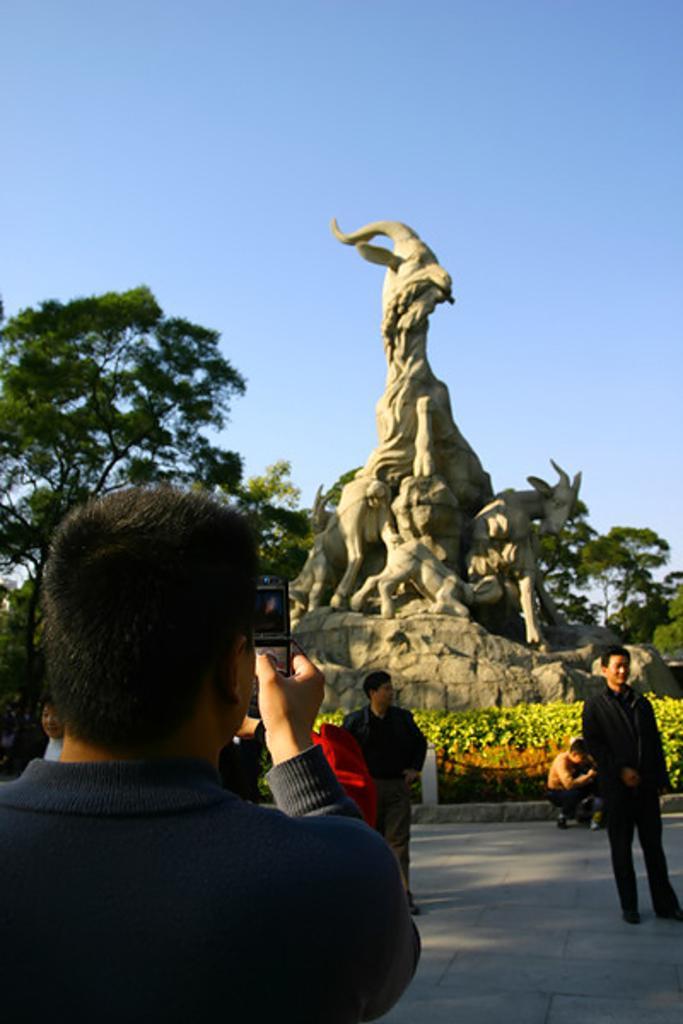Please provide a concise description of this image. In the center of the image, we can see a statue and in the background, there are people, one of them is holding a mobile and we can see trees and plants. At the top, there is sky and at the bottom, there is a road. 